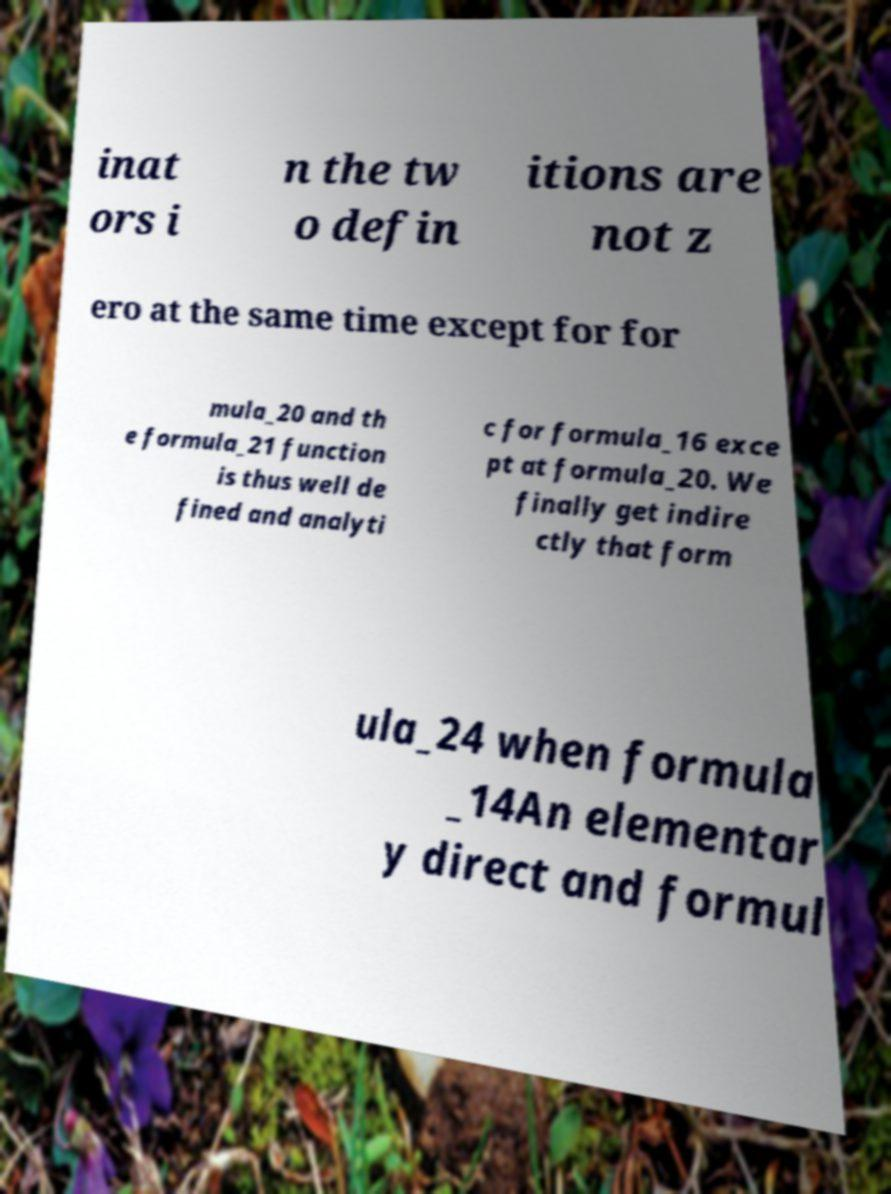Can you accurately transcribe the text from the provided image for me? inat ors i n the tw o defin itions are not z ero at the same time except for for mula_20 and th e formula_21 function is thus well de fined and analyti c for formula_16 exce pt at formula_20. We finally get indire ctly that form ula_24 when formula _14An elementar y direct and formul 